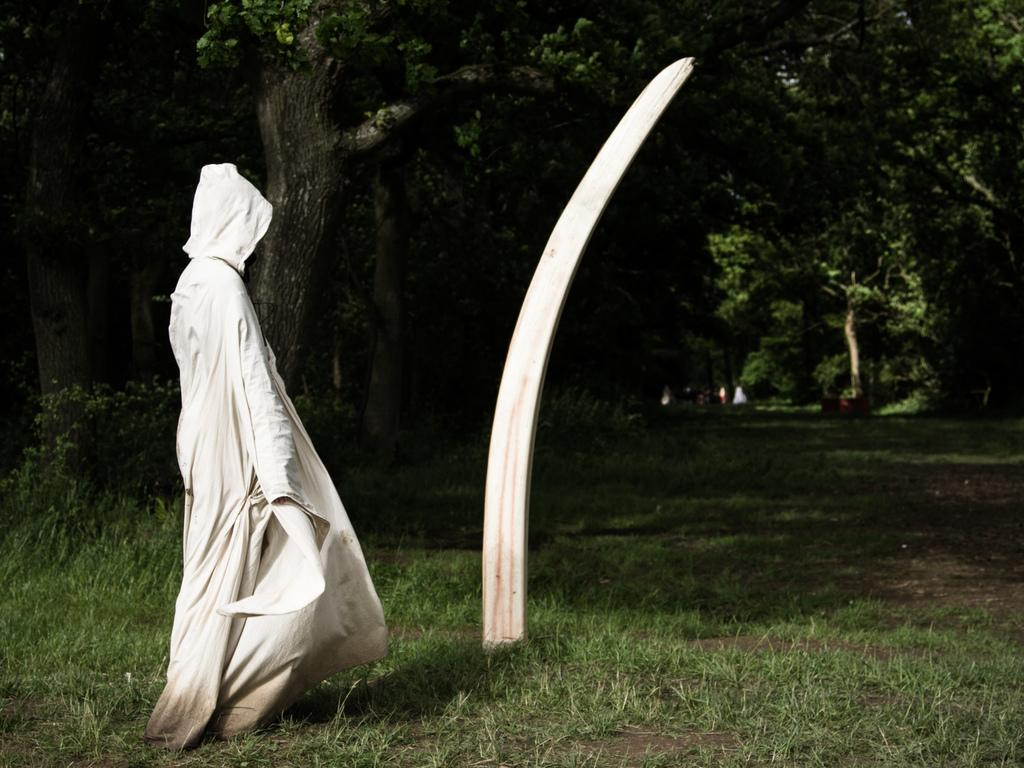Who or what is the main subject in the image? There is a person in the image. What is the person wearing? The person is wearing a white dress. Where is the person standing? The person is standing on grass. What can be seen in the background of the image? There are trees visible at the top of the image. What hobbies does the guide in the image have? There is no guide present in the image, and therefore no hobbies can be attributed to a guide. 